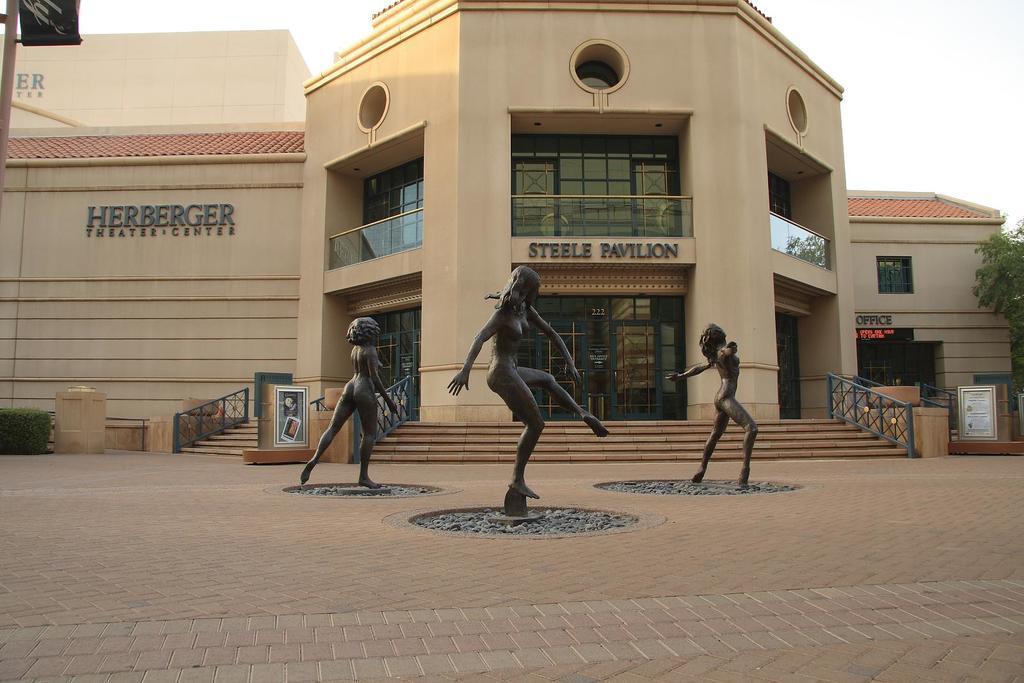Can you describe this image briefly? In this image, we can see a few buildings with glass doors and windows. We can also see some statues. We can also see the ground. There are some stairs and railings. On the right, we can see the tree. On the top, we can see the sky. 